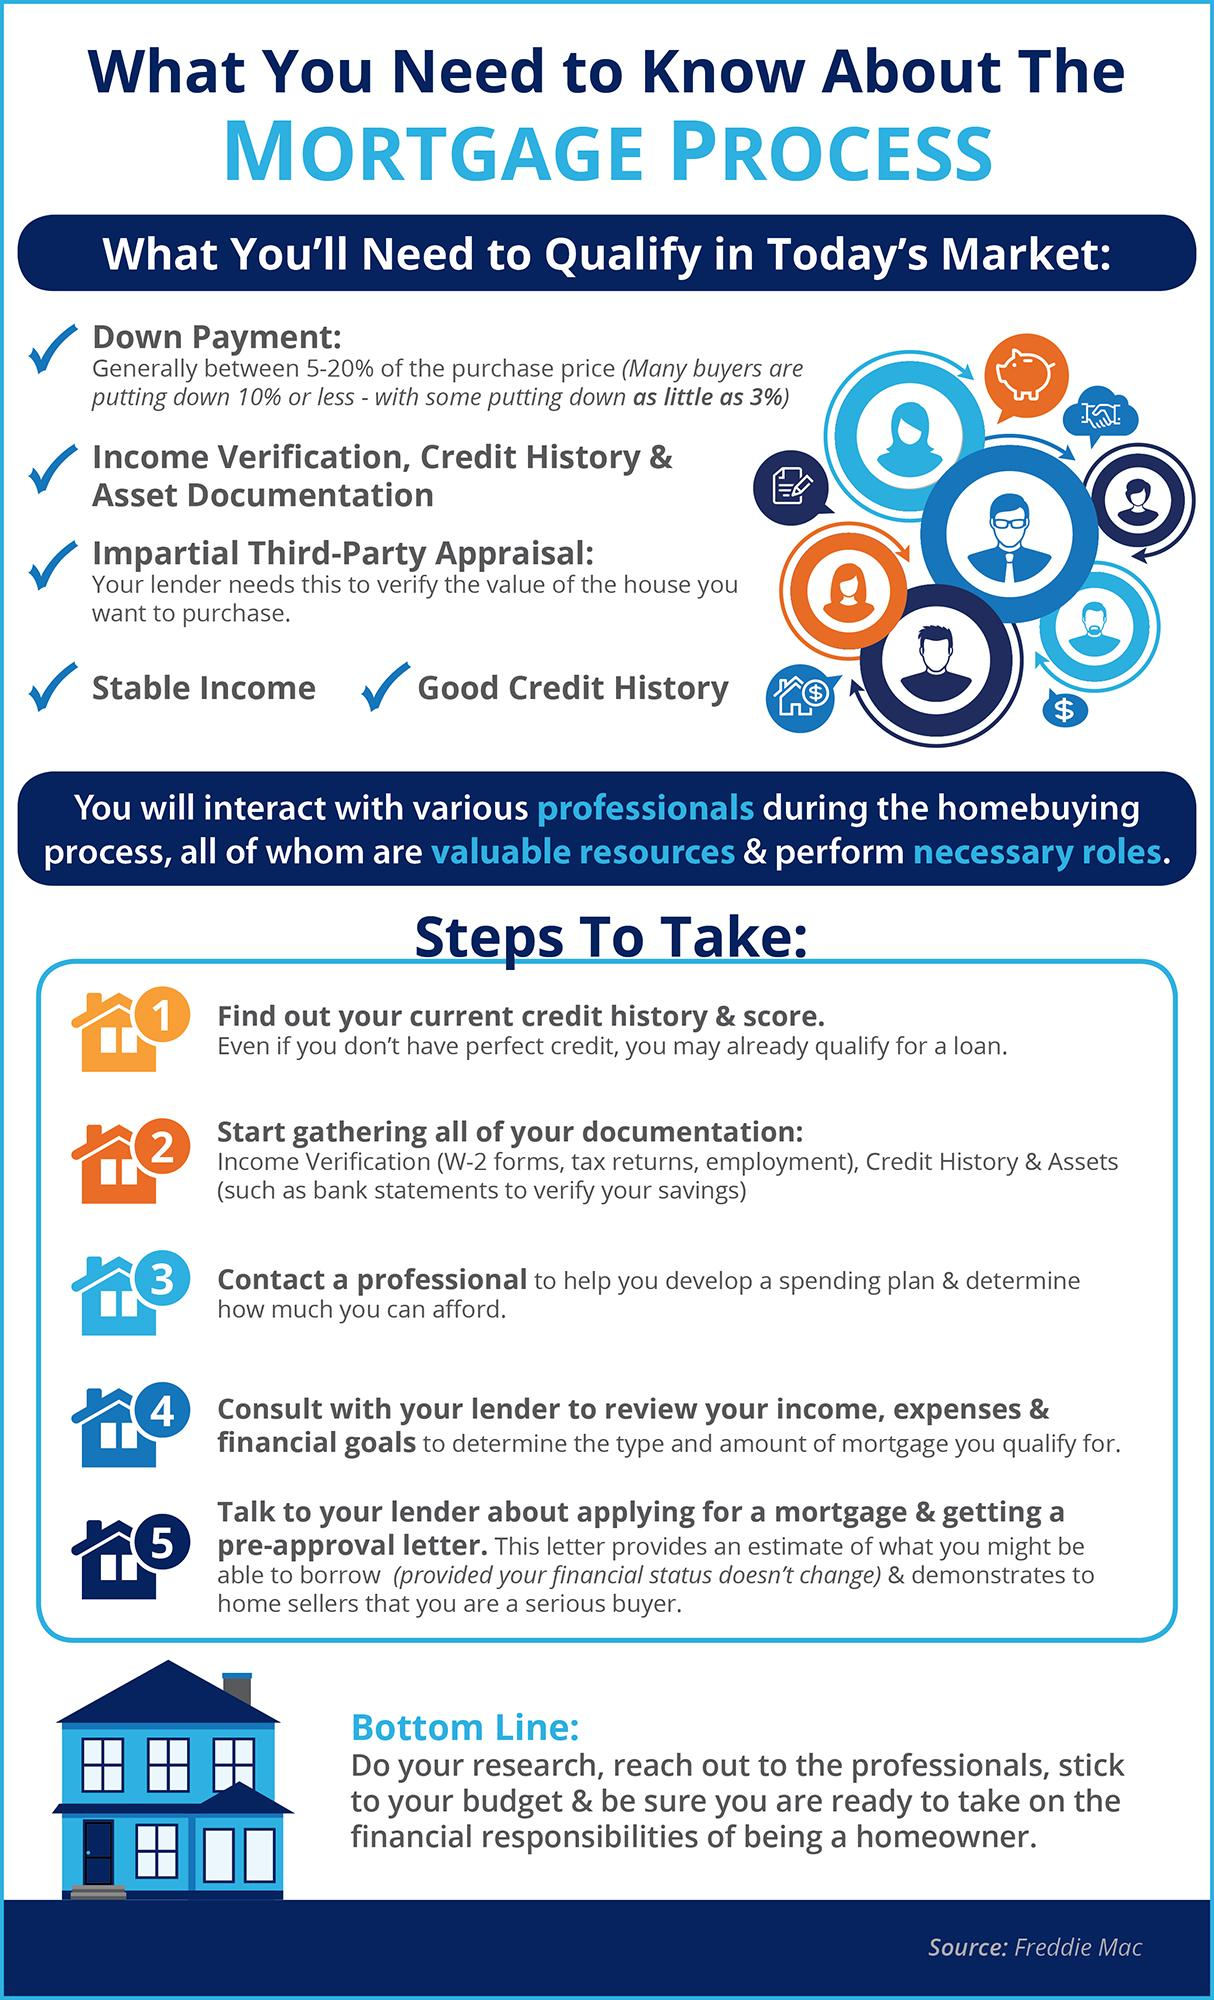Highlight a few significant elements in this photo. It is necessary to take 5 steps for a mortgage. 